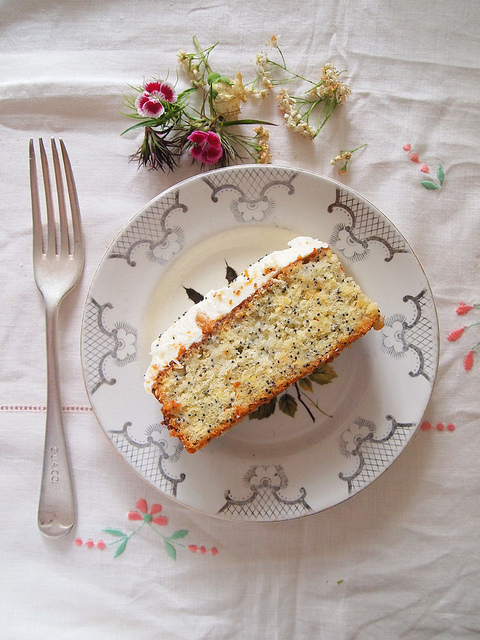Is there any cultural significance to the inclusion of poppy seeds in the cake? Indeed, poppy seeds are often imbued with cultural significance in various culinary traditions. In several European cultures, particularly in Central and Eastern Europe, poppy seeds are widely used in baking. They are viewed as a symbol of wealth and prosperity and are commonly included in celebratory foods. For example, in Hungary and Poland, poppy seed cakes are enjoyed during festive occasions like Christmas and Easter. They bring both a distinct nutty flavor and a subtle crunch, enhancing the sensory experience of the dessert while also carrying a touch of tradition and cultural heritage. 